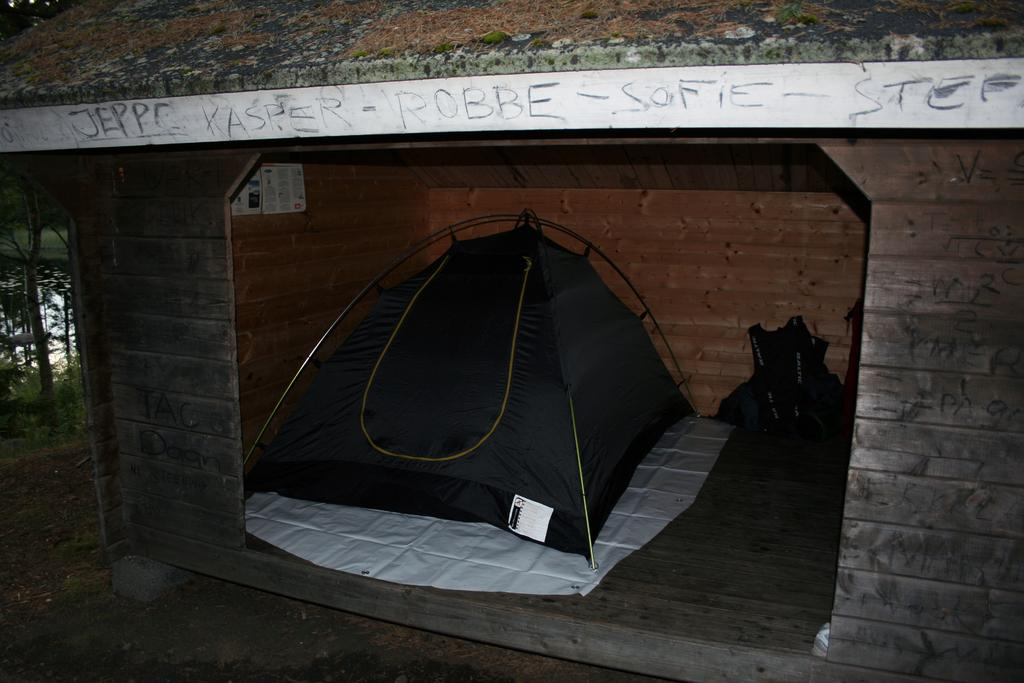What is the main feature of the building in the image? The building has a brick wall. What can be found inside the building? There is a black tent inside the building. What is on the wall of the building? There is a white color board on the wall. What can be seen in the background of the image? In the background, there is water and trees. What type of sack is being used to store grain in the image? There is no sack or grain present in the image. How is the toothpaste being used in the image? There is no toothpaste present in the image. 